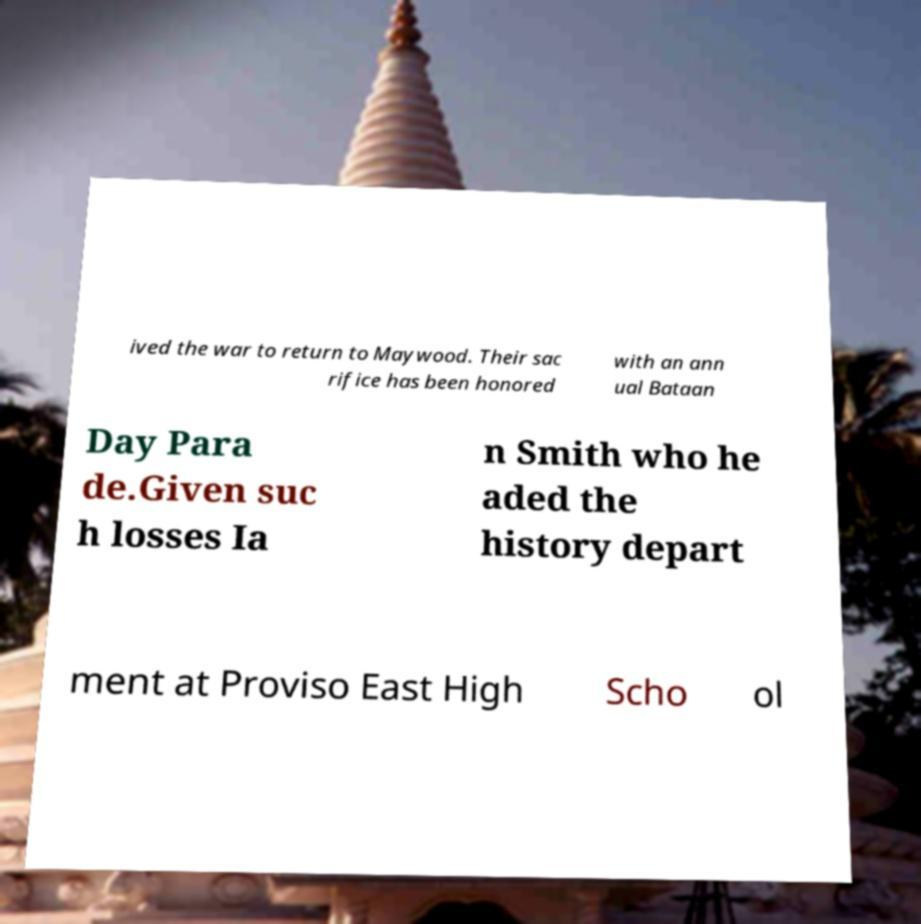Can you accurately transcribe the text from the provided image for me? ived the war to return to Maywood. Their sac rifice has been honored with an ann ual Bataan Day Para de.Given suc h losses Ia n Smith who he aded the history depart ment at Proviso East High Scho ol 